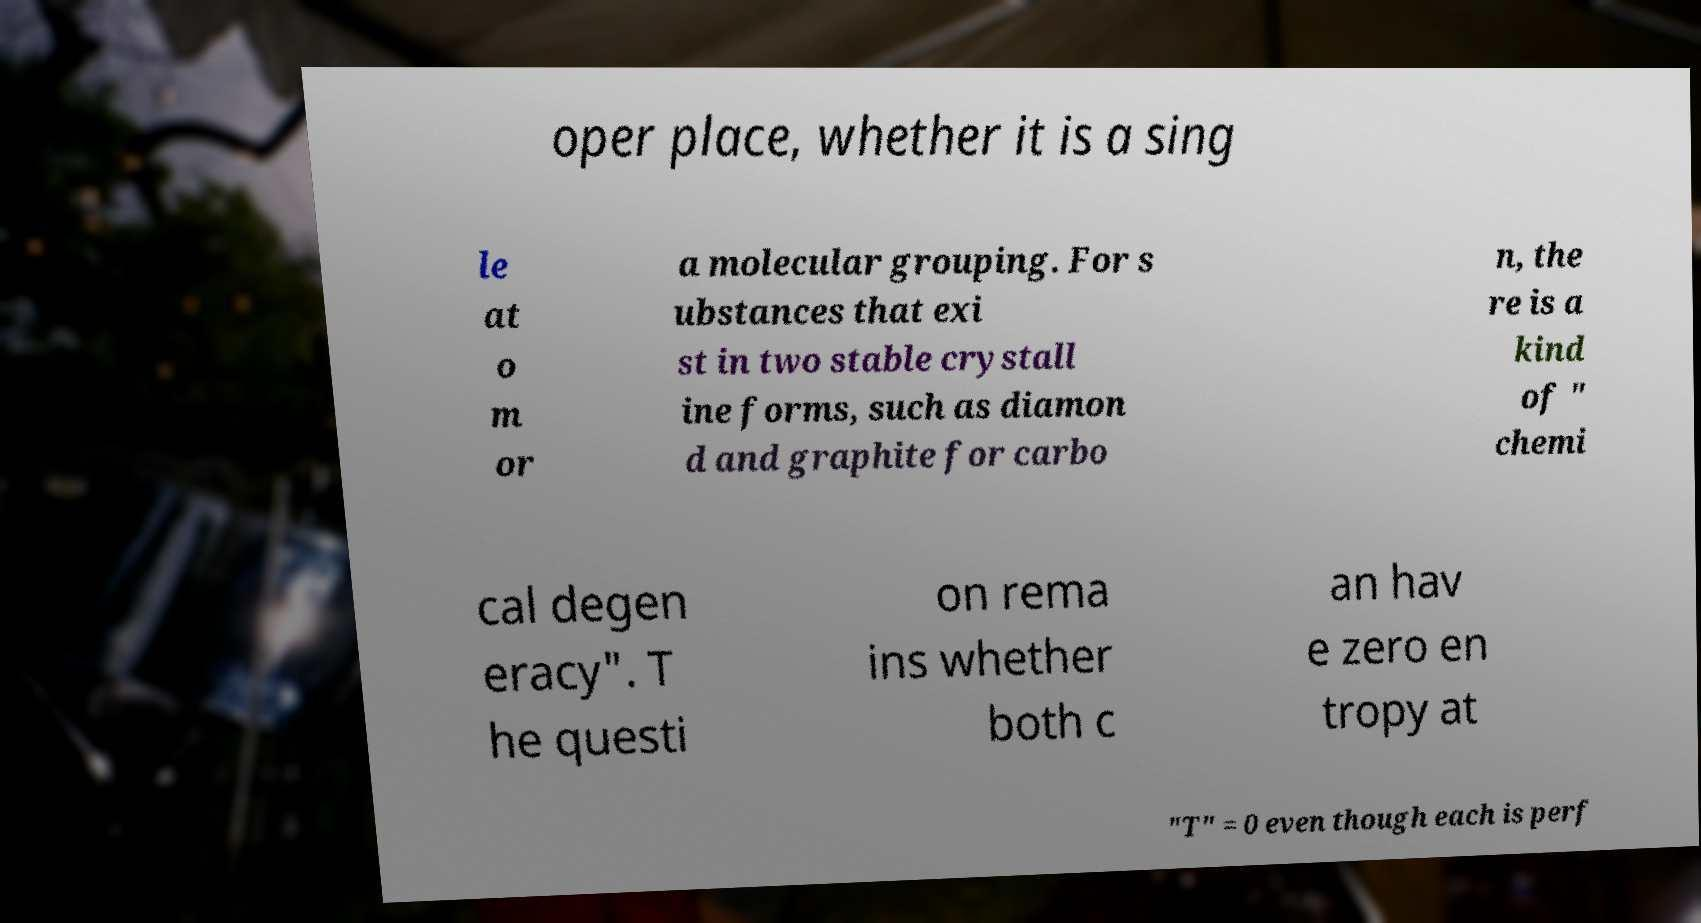I need the written content from this picture converted into text. Can you do that? oper place, whether it is a sing le at o m or a molecular grouping. For s ubstances that exi st in two stable crystall ine forms, such as diamon d and graphite for carbo n, the re is a kind of " chemi cal degen eracy". T he questi on rema ins whether both c an hav e zero en tropy at "T" = 0 even though each is perf 